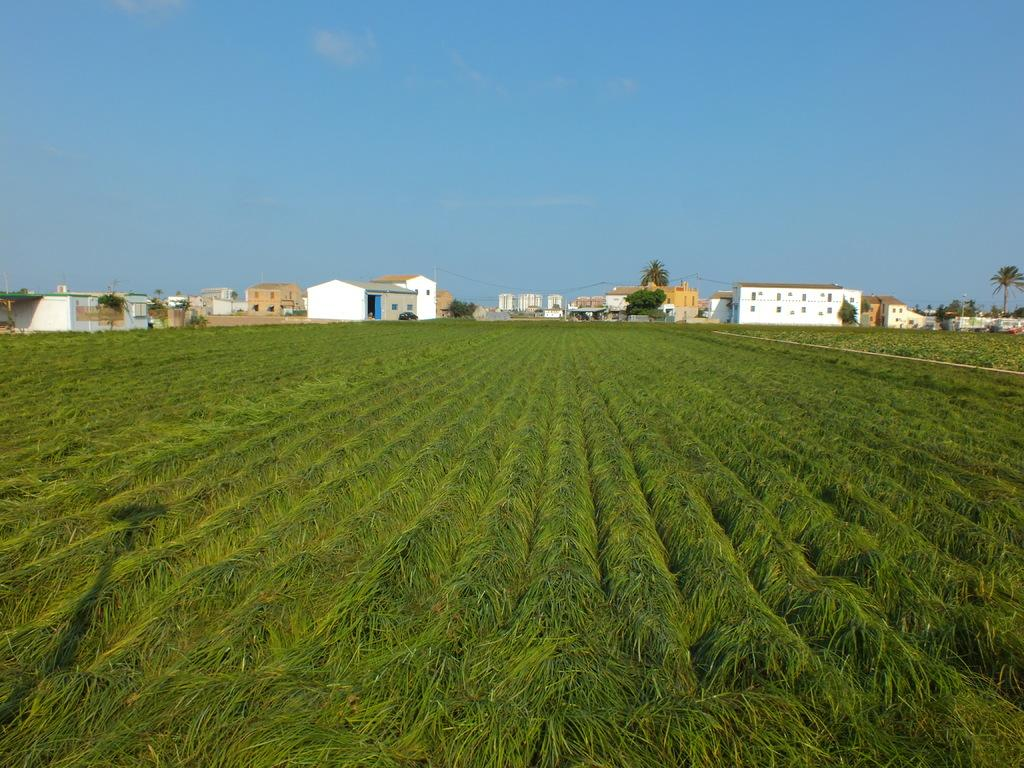What type of landscape is depicted in the image? The image contains agricultural fields. What structures can be seen in the image? There are buildings and sheds in the image. What are the poles used for in the image? The purpose of the poles in the image is not specified, but they could be used for various purposes such as fencing or electrical wiring. What is visible in the background of the image? The sky is visible in the background of the image, with clouds present. What type of throat medicine is being advertised on the sheds in the image? There is no throat medicine or advertisement present in the image; it features agricultural fields, buildings, sheds, poles, and a sky with clouds. 